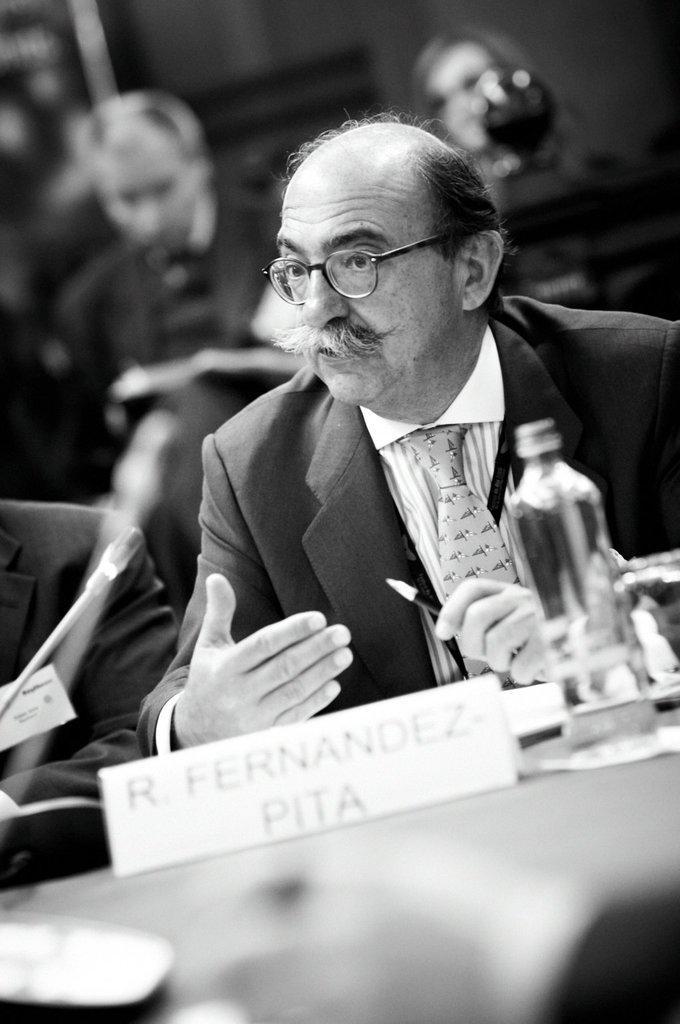In one or two sentences, can you explain what this image depicts? Here a man is sitting on the chair and explaining a something about. He is holding pen in one of his hand. In front of him there is a bottle on the table. There are few people around him. 